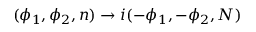Convert formula to latex. <formula><loc_0><loc_0><loc_500><loc_500>( \phi _ { 1 } , \phi _ { 2 } , n ) \rightarrow i ( - \phi _ { 1 } , - \phi _ { 2 } , N )</formula> 